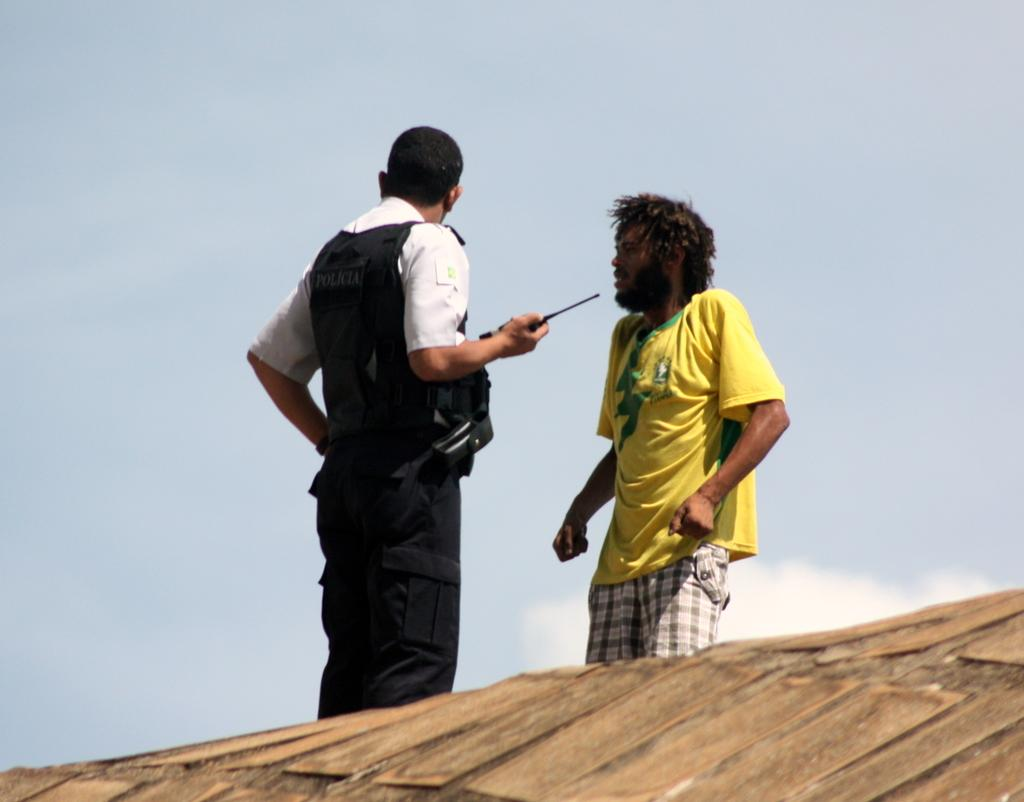How many people are present in the image? There are two people standing in the image. What is at the bottom of the image? There is a surface at the bottom of the image. What can be seen in the background of the image? The sky and clouds are visible in the background of the image. What color is the team's yarn in the image? There is no team or yarn present in the image. 